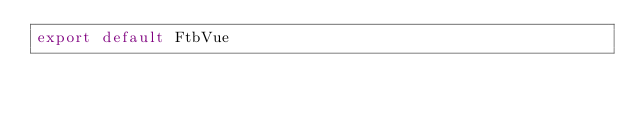Convert code to text. <code><loc_0><loc_0><loc_500><loc_500><_JavaScript_>export default FtbVue
</code> 